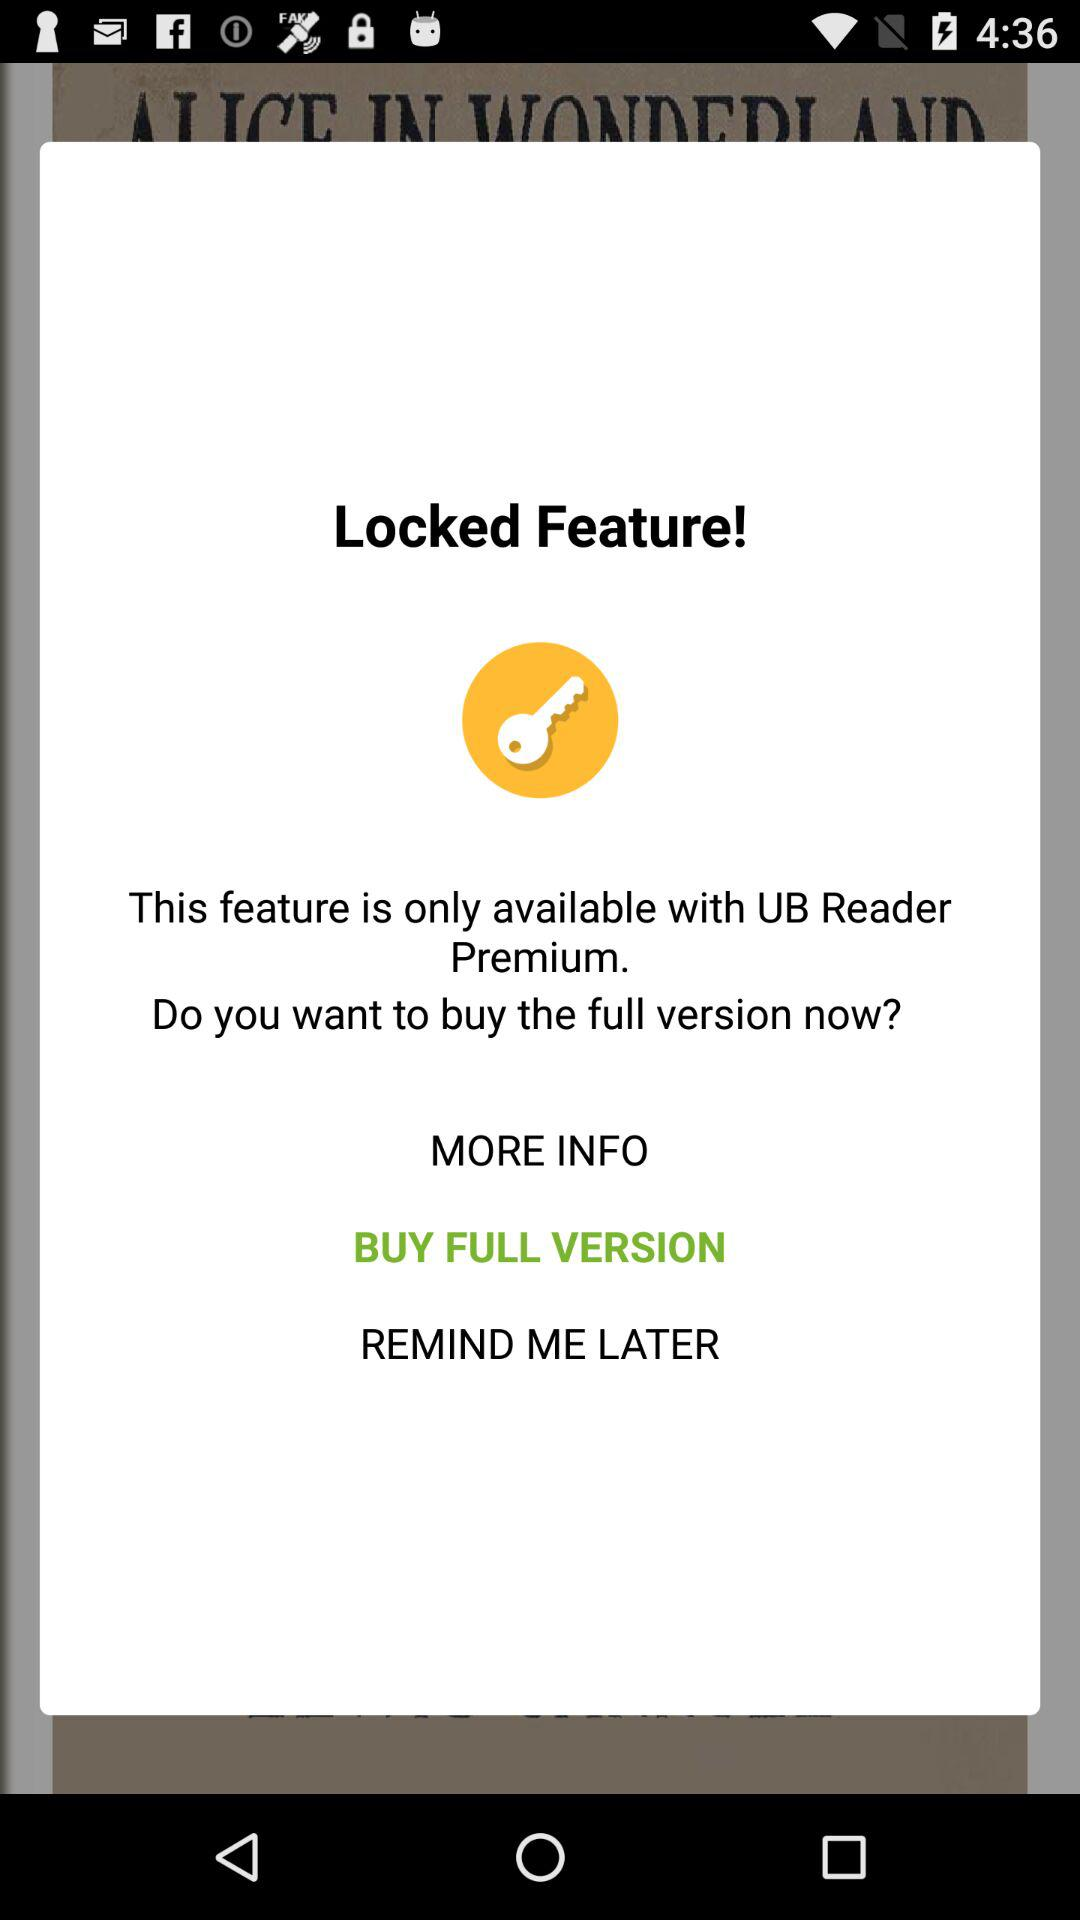What feature is only available with UB Reader Premium? The only available feature is locked feature. 